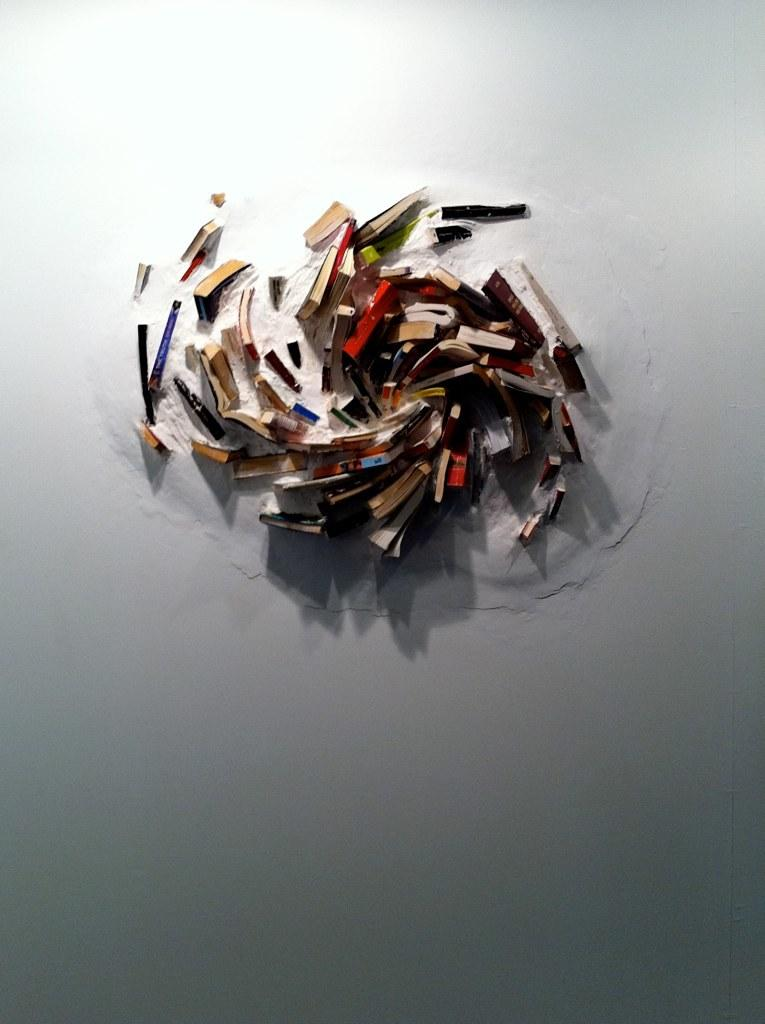What objects can be seen in the image? There are books in the image. What is the color or type of surface in the image? There is a white surface in the image. How many polish bottles are on the white surface in the image? There are: There are no polish bottles present in the image; only books are visible on the white surface. 